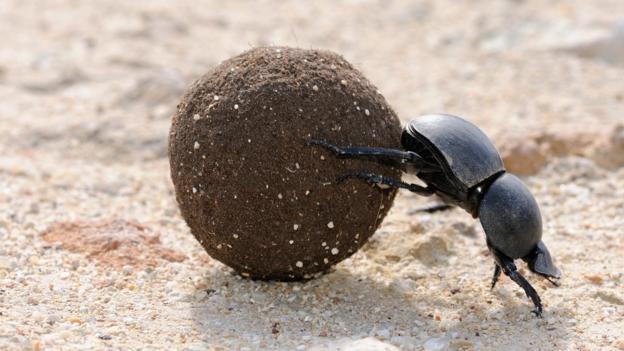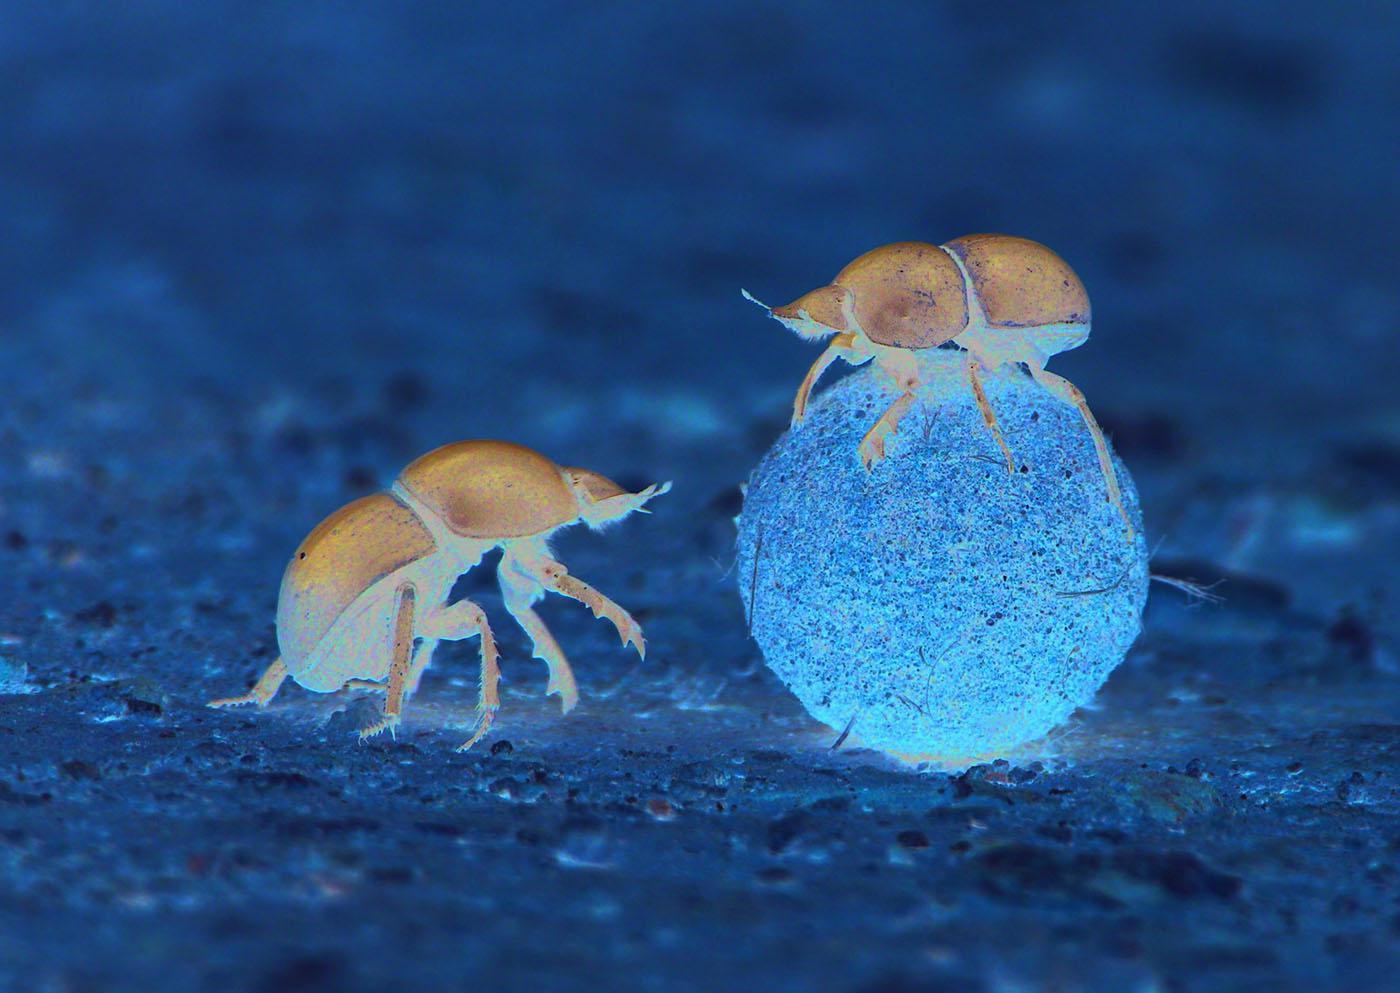The first image is the image on the left, the second image is the image on the right. For the images displayed, is the sentence "Two beetles are near a ball of dirt in one of the images." factually correct? Answer yes or no. Yes. The first image is the image on the left, the second image is the image on the right. Analyze the images presented: Is the assertion "Left image shows just one beetle, with hind legs on dung ball and front legs on ground." valid? Answer yes or no. Yes. 